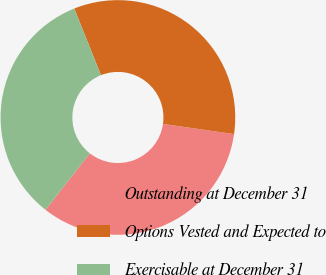<chart> <loc_0><loc_0><loc_500><loc_500><pie_chart><fcel>Outstanding at December 31<fcel>Options Vested and Expected to<fcel>Exercisable at December 31<nl><fcel>33.32%<fcel>33.33%<fcel>33.35%<nl></chart> 